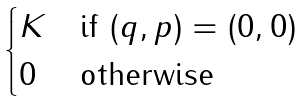<formula> <loc_0><loc_0><loc_500><loc_500>\begin{cases} K & \text {if $(q,p) = (0,0)$} \\ 0 & \text {otherwise} \end{cases}</formula> 